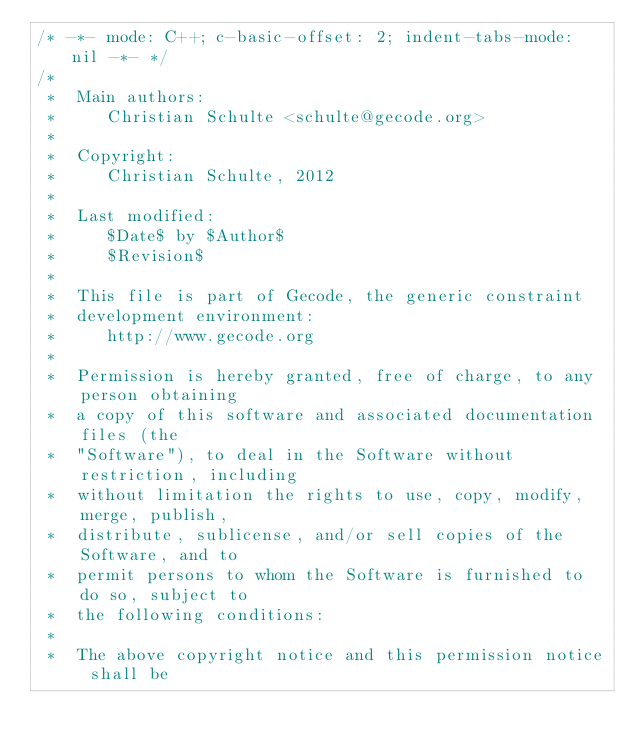<code> <loc_0><loc_0><loc_500><loc_500><_C++_>/* -*- mode: C++; c-basic-offset: 2; indent-tabs-mode: nil -*- */
/*
 *  Main authors:
 *     Christian Schulte <schulte@gecode.org>
 *
 *  Copyright:
 *     Christian Schulte, 2012
 *
 *  Last modified:
 *     $Date$ by $Author$
 *     $Revision$
 *
 *  This file is part of Gecode, the generic constraint
 *  development environment:
 *     http://www.gecode.org
 *
 *  Permission is hereby granted, free of charge, to any person obtaining
 *  a copy of this software and associated documentation files (the
 *  "Software"), to deal in the Software without restriction, including
 *  without limitation the rights to use, copy, modify, merge, publish,
 *  distribute, sublicense, and/or sell copies of the Software, and to
 *  permit persons to whom the Software is furnished to do so, subject to
 *  the following conditions:
 *
 *  The above copyright notice and this permission notice shall be</code> 